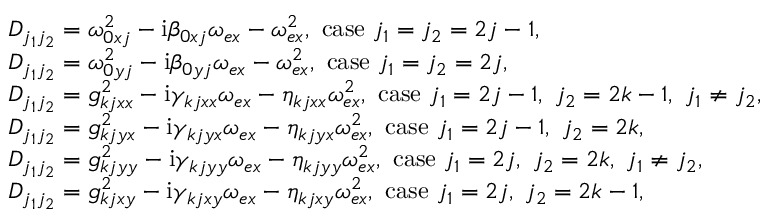<formula> <loc_0><loc_0><loc_500><loc_500>\begin{array} { r l } & { D _ { j _ { 1 } j _ { 2 } } = \omega _ { 0 x j } ^ { 2 } - i \beta _ { 0 x j } \omega _ { e x } - \omega _ { e x } ^ { 2 } , c a s e j _ { 1 } = j _ { 2 } = 2 j - 1 , } \\ & { D _ { j _ { 1 } j _ { 2 } } = \omega _ { 0 y j } ^ { 2 } - i \beta _ { 0 y j } \omega _ { e x } - \omega _ { e x } ^ { 2 } , c a s e j _ { 1 } = j _ { 2 } = 2 j , } \\ & { D _ { j _ { 1 } j _ { 2 } } = g _ { k j x x } ^ { 2 } - i \gamma _ { k j x x } \omega _ { e x } - \eta _ { k j x x } \omega _ { e x } ^ { 2 } , c a s e j _ { 1 } = 2 j - 1 , j _ { 2 } = 2 k - 1 , j _ { 1 } \neq j _ { 2 } , } \\ & { D _ { j _ { 1 } j _ { 2 } } = g _ { k j y x } ^ { 2 } - i \gamma _ { k j y x } \omega _ { e x } - \eta _ { k j y x } \omega _ { e x } ^ { 2 } , c a s e j _ { 1 } = 2 j - 1 , j _ { 2 } = 2 k , } \\ & { D _ { j _ { 1 } j _ { 2 } } = g _ { k j y y } ^ { 2 } - i \gamma _ { k j y y } \omega _ { e x } - \eta _ { k j y y } \omega _ { e x } ^ { 2 } , c a s e j _ { 1 } = 2 j , j _ { 2 } = 2 k , j _ { 1 } \neq j _ { 2 } , } \\ & { D _ { j _ { 1 } j _ { 2 } } = g _ { k j x y } ^ { 2 } - i \gamma _ { k j x y } \omega _ { e x } - \eta _ { k j x y } \omega _ { e x } ^ { 2 } , c a s e j _ { 1 } = 2 j , j _ { 2 } = 2 k - 1 , } \end{array}</formula> 